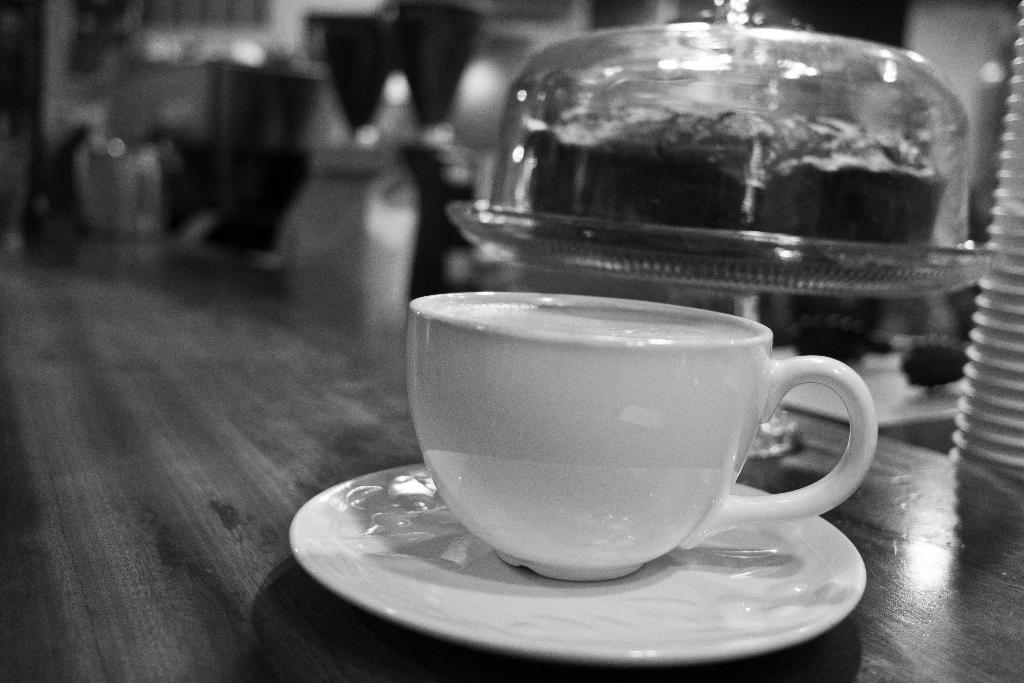What type of dishware can be seen in the image? There is a cup, a saucer, a bowl, and a plate in the image. Where are these objects located? All these objects are on a table. What might be used for holding liquids in the image? The cup in the image might be used for holding liquids. What might be used for serving food in the image? The bowl and plate in the image might be used for serving food. Can you see a drum being played in the image? No, there is no drum or any musical instrument visible in the image. What type of wind is blowing in the image? There is no mention of wind or any weather-related elements in the image. 